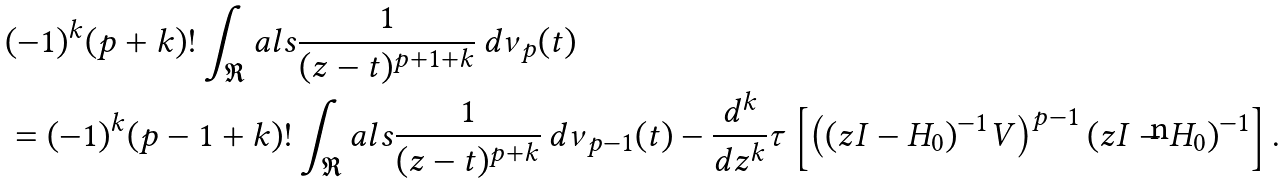<formula> <loc_0><loc_0><loc_500><loc_500>& ( - 1 ) ^ { k } ( p + k ) ! \int _ { \Re } a l s \frac { 1 } { ( z - t ) ^ { p + 1 + k } } \, d \nu _ { p } ( t ) \\ & = ( - 1 ) ^ { k } ( p - 1 + k ) ! \int _ { \Re } a l s \frac { 1 } { ( z - t ) ^ { p + k } } \, d \nu _ { p - 1 } ( t ) - \frac { d ^ { k } } { d z ^ { k } } \tau \left [ \left ( ( z I - H _ { 0 } ) ^ { - 1 } V \right ) ^ { p - 1 } ( z I - H _ { 0 } ) ^ { - 1 } \right ] .</formula> 